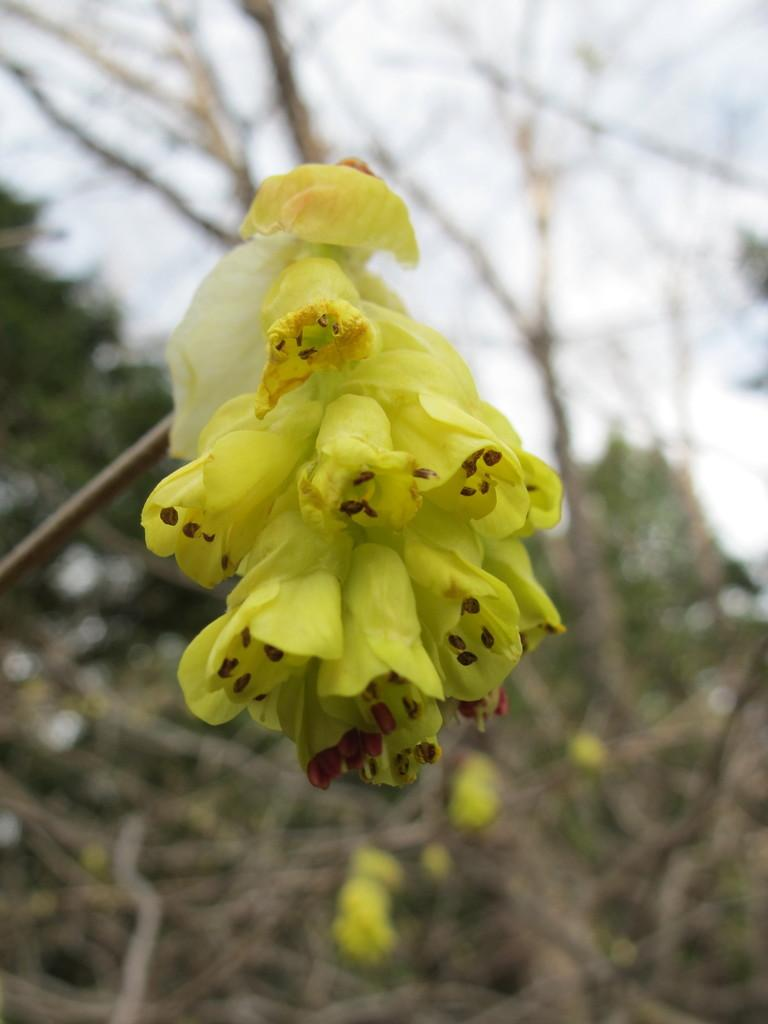What is the main subject of the image? The main subject of the image is a bunch of flowers. Where are the flowers located? The flowers are on a plant. Can you tell me how many kittens are playing with a loaf of bread on the hill in the image? There are no kittens, loaves of bread, or hills present in the image; it features a bunch of flowers on a plant. 